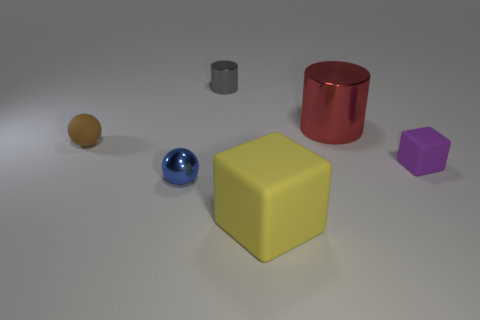What size is the other rubber thing that is the same shape as the big yellow object?
Keep it short and to the point. Small. What is the size of the metal thing that is left of the gray metallic thing?
Ensure brevity in your answer.  Small. Do the tiny metal object behind the blue metallic ball and the small rubber block have the same color?
Make the answer very short. No. What number of tiny gray shiny objects are the same shape as the purple rubber thing?
Your answer should be very brief. 0. How many objects are things that are behind the brown rubber ball or metallic cylinders that are to the left of the yellow block?
Make the answer very short. 2. How many red objects are either tiny metallic things or large cylinders?
Give a very brief answer. 1. There is a thing that is on the left side of the purple rubber thing and to the right of the big yellow matte thing; what material is it made of?
Give a very brief answer. Metal. Do the gray object and the big block have the same material?
Your answer should be compact. No. How many metallic objects are the same size as the purple matte thing?
Give a very brief answer. 2. Are there the same number of large red metal things that are on the left side of the blue metallic ball and brown things?
Your answer should be very brief. No. 